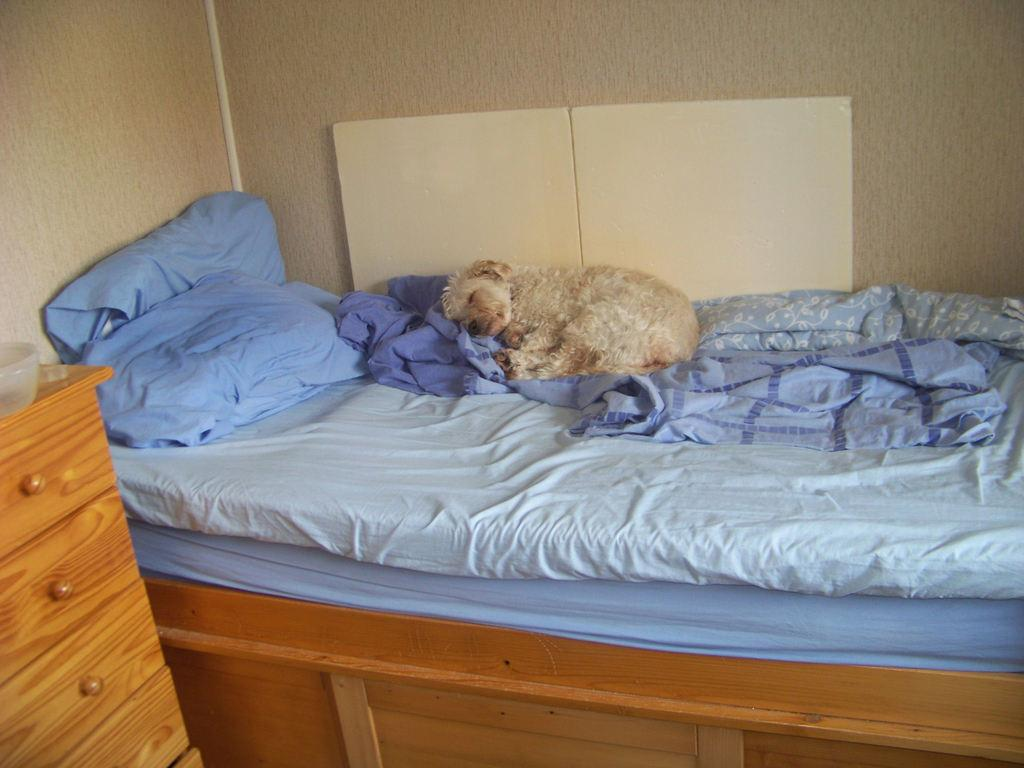What is on the bed in the image? There is a blue blanket and blue pillows on the bed. What is lying on the bed? A dog is lying on the bed. What can be seen on the cupboard in the image? There is a bowl on the cupboard. What is present in the background of the image? There is a wall in the background of the image. What is the income of the wren that is sitting on the wall in the image? There is no wren present in the image, and therefore no income can be determined. 